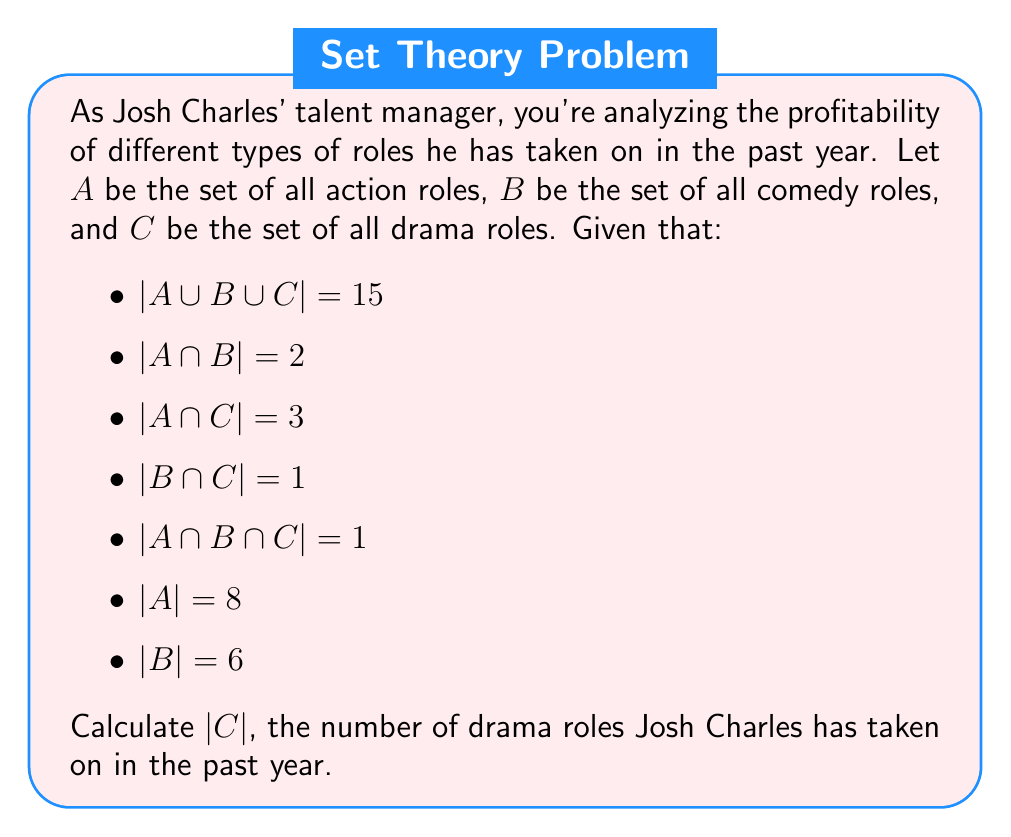Provide a solution to this math problem. To solve this problem, we'll use the Inclusion-Exclusion Principle for three sets:

$$|A \cup B \cup C| = |A| + |B| + |C| - |A \cap B| - |A \cap C| - |B \cap C| + |A \cap B \cap C|$$

We're given most of these values, so let's substitute them into the equation:

$$15 = 8 + 6 + |C| - 2 - 3 - 1 + 1$$

Now, let's solve for $|C|$:

$$15 = 8 + 6 + |C| - 5$$
$$15 = 9 + |C|$$
$$|C| = 15 - 9 = 6$$

Therefore, Josh Charles has taken on 6 drama roles in the past year.

To verify, we can check if this satisfies all the given conditions:
1. $|A \cup B \cup C| = 15$ (given)
2. $|A| = 8$, $|B| = 6$, $|C| = 6$ (calculated)
3. $|A \cap B| = 2$, $|A \cap C| = 3$, $|B \cap C| = 1$, $|A \cap B \cap C| = 1$ (given)

These values satisfy the Inclusion-Exclusion Principle, confirming our calculation.
Answer: $|C| = 6$ 